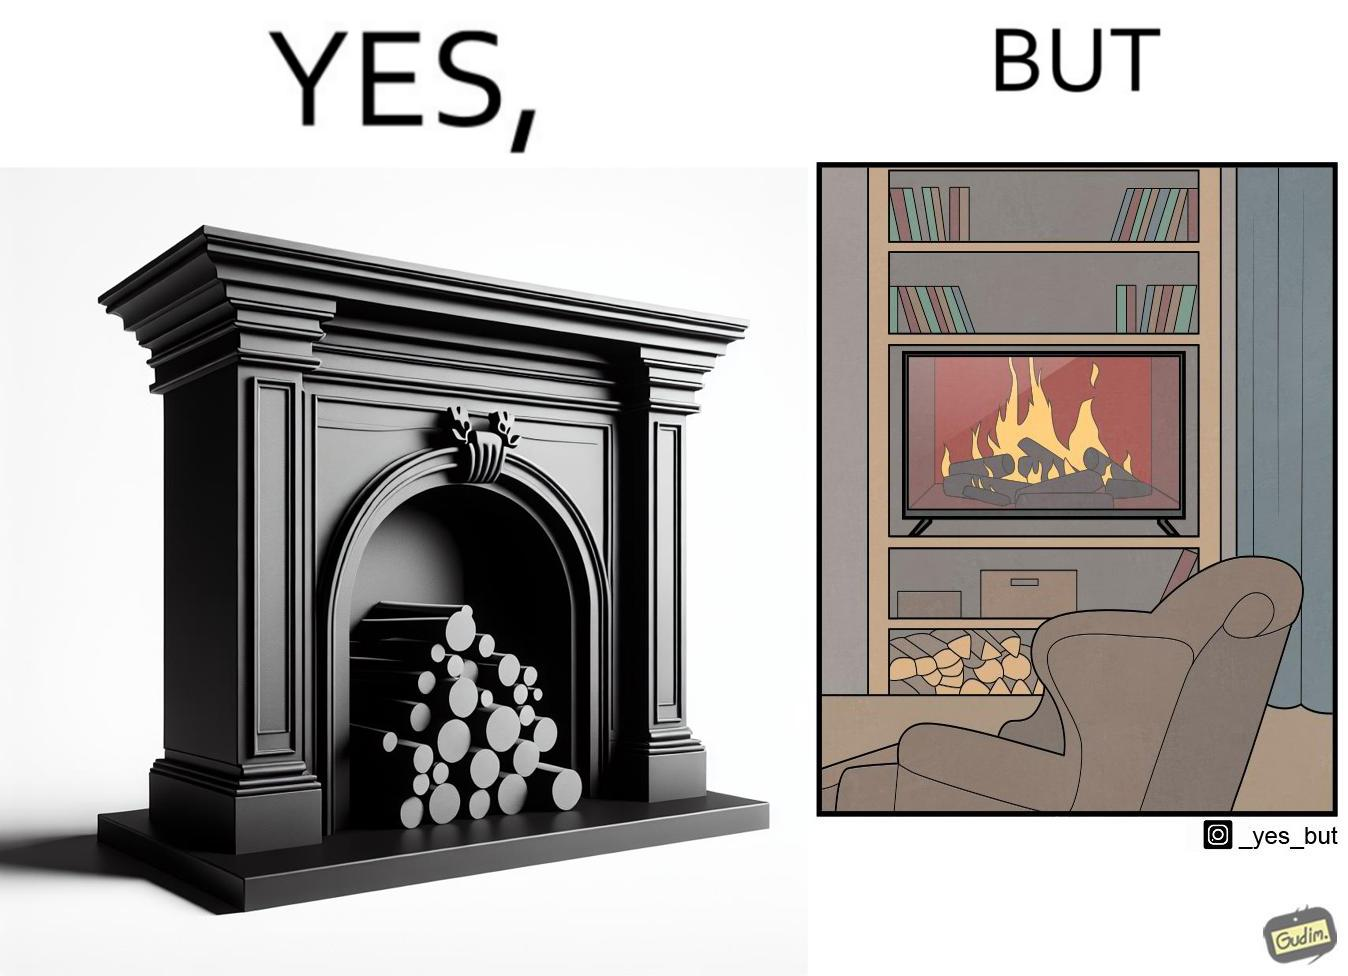Why is this image considered satirical? The images are funny since they show how even though real fireplaces exist, people choose to be lazy and watch fireplaces on television because they dont want the inconveniences of cleaning up, etc. afterwards 